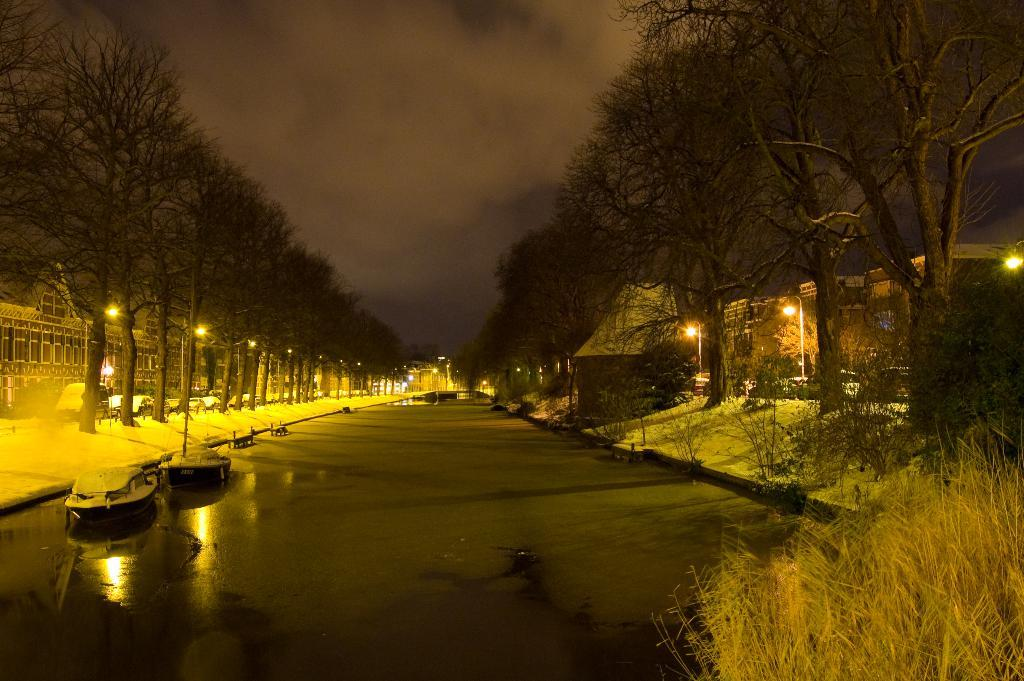What is the main subject of the image? The main subject of the image is boats on water. What else can be seen in the image besides the boats? Trees, lights, buildings, and the sky with clouds are visible in the image. Where is the bun being held by the kitty in the image? There is no bun or kitty present in the image. What part of the brain can be seen in the image? There is no brain visible in the image. 